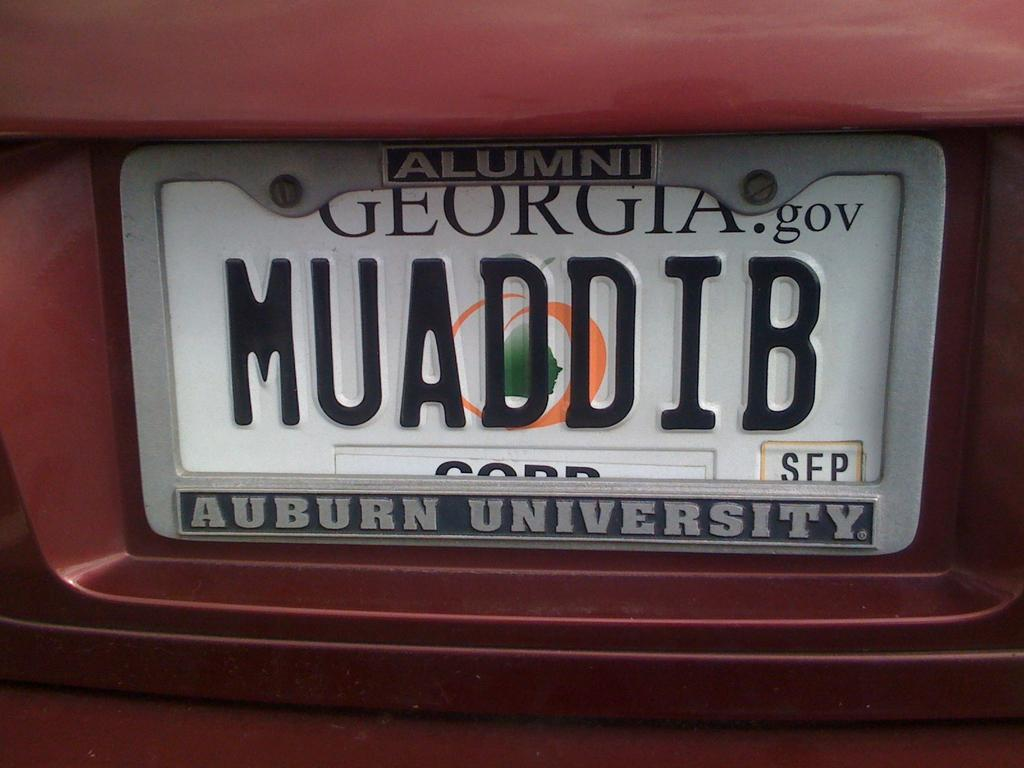Provide a one-sentence caption for the provided image. An Auburn Unoversity frame surrounds the Georgia license plate. 